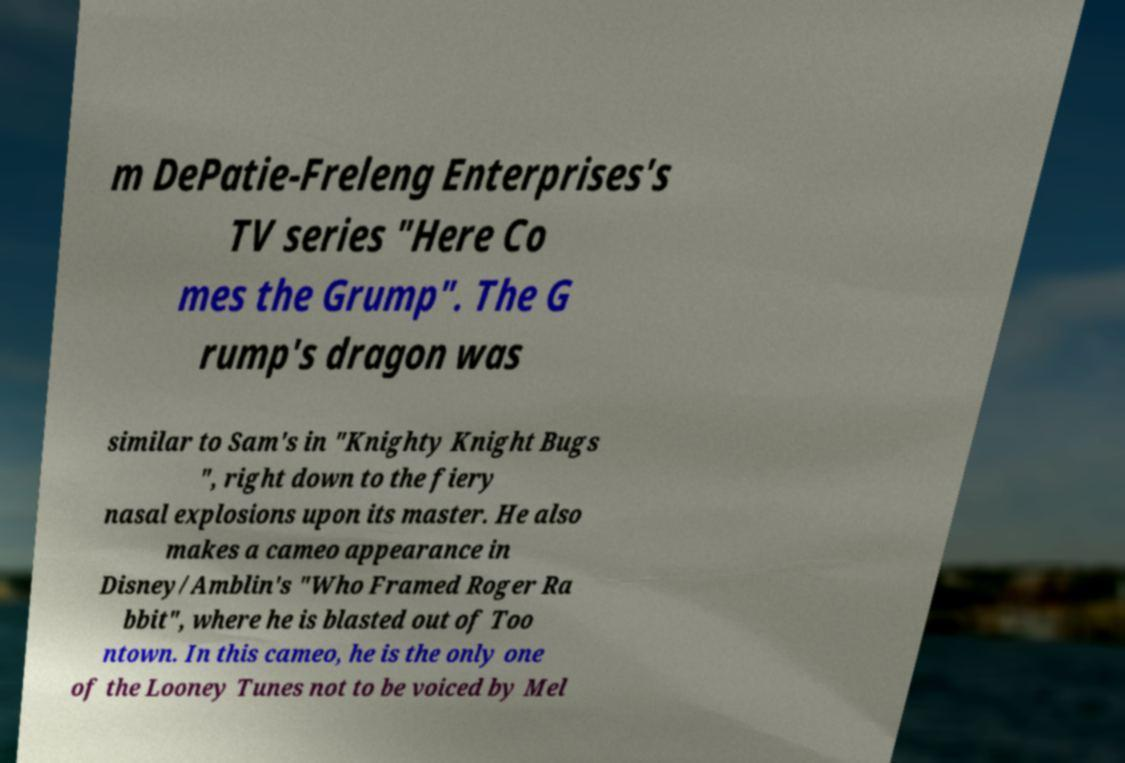Can you read and provide the text displayed in the image?This photo seems to have some interesting text. Can you extract and type it out for me? m DePatie-Freleng Enterprises's TV series "Here Co mes the Grump". The G rump's dragon was similar to Sam's in "Knighty Knight Bugs ", right down to the fiery nasal explosions upon its master. He also makes a cameo appearance in Disney/Amblin's "Who Framed Roger Ra bbit", where he is blasted out of Too ntown. In this cameo, he is the only one of the Looney Tunes not to be voiced by Mel 